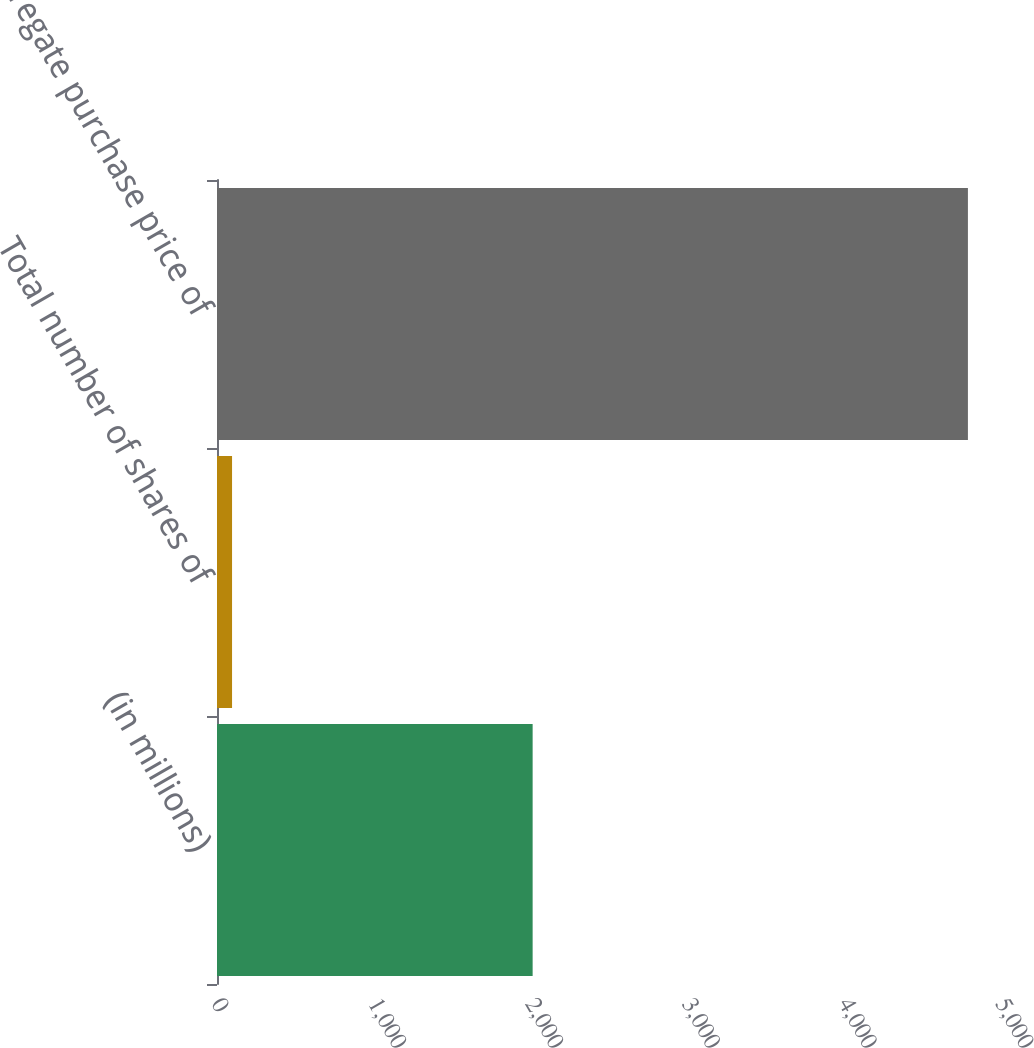<chart> <loc_0><loc_0><loc_500><loc_500><bar_chart><fcel>(in millions)<fcel>Total number of shares of<fcel>Aggregate purchase price of<nl><fcel>2013<fcel>96<fcel>4789<nl></chart> 